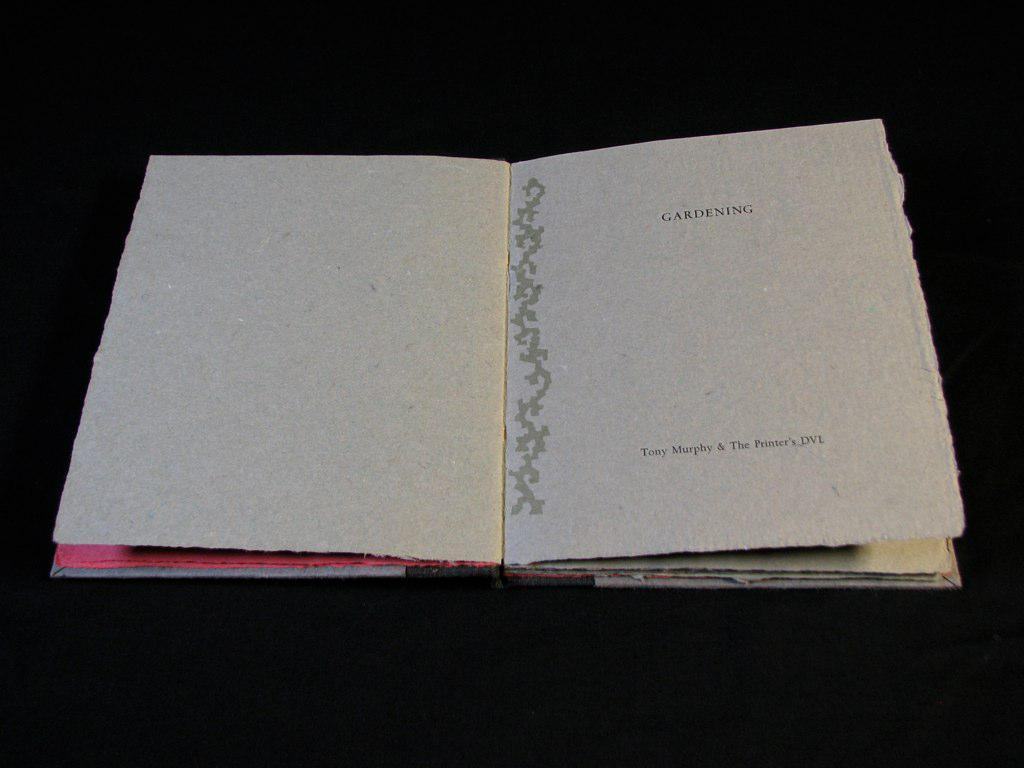<image>
Create a compact narrative representing the image presented. An open book that has the title Gardening on a blank page 